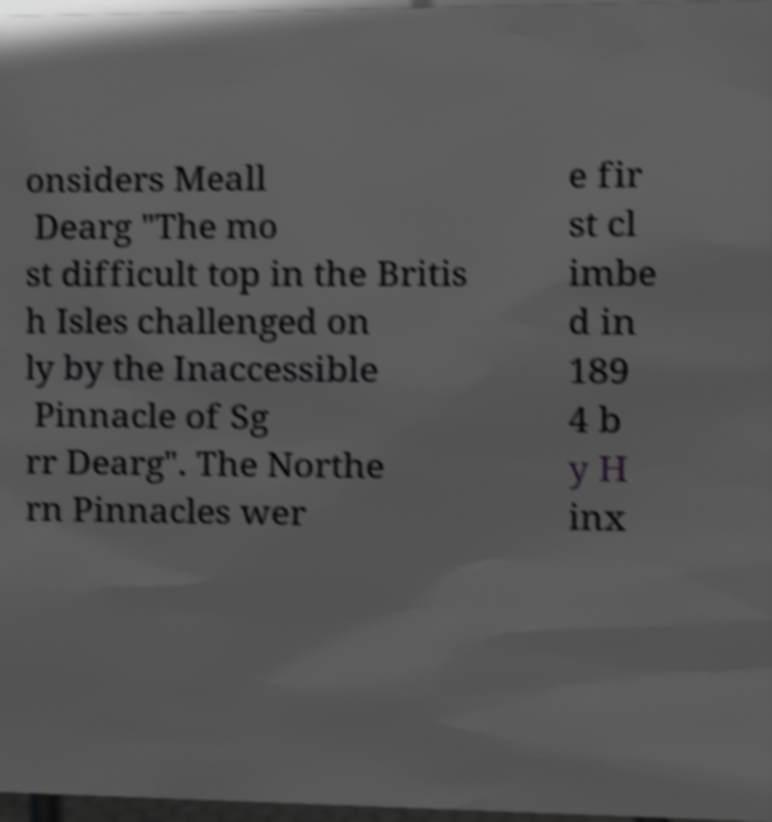Please read and relay the text visible in this image. What does it say? onsiders Meall Dearg "The mo st difficult top in the Britis h Isles challenged on ly by the Inaccessible Pinnacle of Sg rr Dearg". The Northe rn Pinnacles wer e fir st cl imbe d in 189 4 b y H inx 